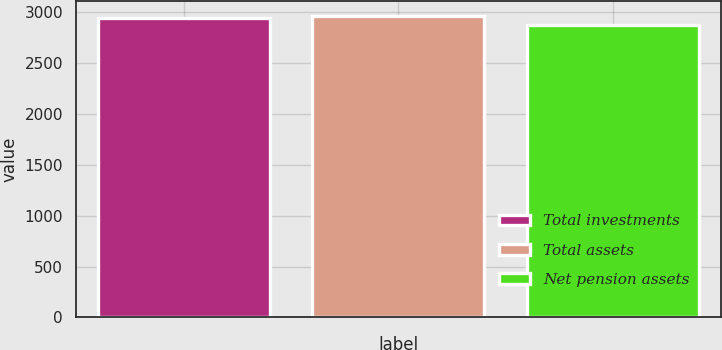Convert chart to OTSL. <chart><loc_0><loc_0><loc_500><loc_500><bar_chart><fcel>Total investments<fcel>Total assets<fcel>Net pension assets<nl><fcel>2943<fcel>2963<fcel>2867<nl></chart> 